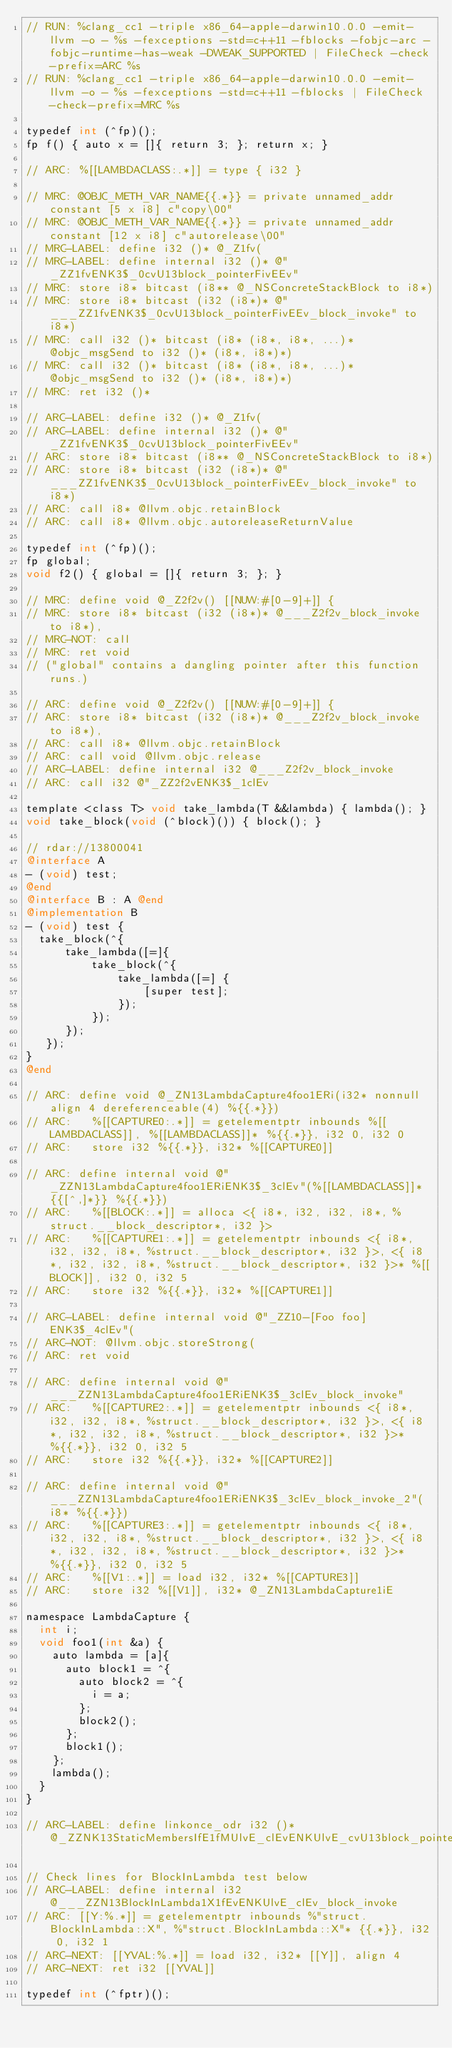<code> <loc_0><loc_0><loc_500><loc_500><_ObjectiveC_>// RUN: %clang_cc1 -triple x86_64-apple-darwin10.0.0 -emit-llvm -o - %s -fexceptions -std=c++11 -fblocks -fobjc-arc -fobjc-runtime-has-weak -DWEAK_SUPPORTED | FileCheck -check-prefix=ARC %s
// RUN: %clang_cc1 -triple x86_64-apple-darwin10.0.0 -emit-llvm -o - %s -fexceptions -std=c++11 -fblocks | FileCheck -check-prefix=MRC %s

typedef int (^fp)();
fp f() { auto x = []{ return 3; }; return x; }

// ARC: %[[LAMBDACLASS:.*]] = type { i32 }

// MRC: @OBJC_METH_VAR_NAME{{.*}} = private unnamed_addr constant [5 x i8] c"copy\00"
// MRC: @OBJC_METH_VAR_NAME{{.*}} = private unnamed_addr constant [12 x i8] c"autorelease\00"
// MRC-LABEL: define i32 ()* @_Z1fv(
// MRC-LABEL: define internal i32 ()* @"_ZZ1fvENK3$_0cvU13block_pointerFivEEv"
// MRC: store i8* bitcast (i8** @_NSConcreteStackBlock to i8*)
// MRC: store i8* bitcast (i32 (i8*)* @"___ZZ1fvENK3$_0cvU13block_pointerFivEEv_block_invoke" to i8*)
// MRC: call i32 ()* bitcast (i8* (i8*, i8*, ...)* @objc_msgSend to i32 ()* (i8*, i8*)*)
// MRC: call i32 ()* bitcast (i8* (i8*, i8*, ...)* @objc_msgSend to i32 ()* (i8*, i8*)*)
// MRC: ret i32 ()*

// ARC-LABEL: define i32 ()* @_Z1fv(
// ARC-LABEL: define internal i32 ()* @"_ZZ1fvENK3$_0cvU13block_pointerFivEEv"
// ARC: store i8* bitcast (i8** @_NSConcreteStackBlock to i8*)
// ARC: store i8* bitcast (i32 (i8*)* @"___ZZ1fvENK3$_0cvU13block_pointerFivEEv_block_invoke" to i8*)
// ARC: call i8* @llvm.objc.retainBlock
// ARC: call i8* @llvm.objc.autoreleaseReturnValue

typedef int (^fp)();
fp global;
void f2() { global = []{ return 3; }; }

// MRC: define void @_Z2f2v() [[NUW:#[0-9]+]] {
// MRC: store i8* bitcast (i32 (i8*)* @___Z2f2v_block_invoke to i8*),
// MRC-NOT: call
// MRC: ret void
// ("global" contains a dangling pointer after this function runs.)

// ARC: define void @_Z2f2v() [[NUW:#[0-9]+]] {
// ARC: store i8* bitcast (i32 (i8*)* @___Z2f2v_block_invoke to i8*),
// ARC: call i8* @llvm.objc.retainBlock
// ARC: call void @llvm.objc.release
// ARC-LABEL: define internal i32 @___Z2f2v_block_invoke
// ARC: call i32 @"_ZZ2f2vENK3$_1clEv

template <class T> void take_lambda(T &&lambda) { lambda(); }
void take_block(void (^block)()) { block(); }

// rdar://13800041
@interface A
- (void) test;
@end
@interface B : A @end
@implementation B
- (void) test {
  take_block(^{
      take_lambda([=]{
          take_block(^{
              take_lambda([=] {
                  [super test];
              });
          });
      });
   });
}
@end

// ARC: define void @_ZN13LambdaCapture4foo1ERi(i32* nonnull align 4 dereferenceable(4) %{{.*}})
// ARC:   %[[CAPTURE0:.*]] = getelementptr inbounds %[[LAMBDACLASS]], %[[LAMBDACLASS]]* %{{.*}}, i32 0, i32 0
// ARC:   store i32 %{{.*}}, i32* %[[CAPTURE0]]

// ARC: define internal void @"_ZZN13LambdaCapture4foo1ERiENK3$_3clEv"(%[[LAMBDACLASS]]* {{[^,]*}} %{{.*}})
// ARC:   %[[BLOCK:.*]] = alloca <{ i8*, i32, i32, i8*, %struct.__block_descriptor*, i32 }>
// ARC:   %[[CAPTURE1:.*]] = getelementptr inbounds <{ i8*, i32, i32, i8*, %struct.__block_descriptor*, i32 }>, <{ i8*, i32, i32, i8*, %struct.__block_descriptor*, i32 }>* %[[BLOCK]], i32 0, i32 5
// ARC:   store i32 %{{.*}}, i32* %[[CAPTURE1]]

// ARC-LABEL: define internal void @"_ZZ10-[Foo foo]ENK3$_4clEv"(
// ARC-NOT: @llvm.objc.storeStrong(
// ARC: ret void

// ARC: define internal void @"___ZZN13LambdaCapture4foo1ERiENK3$_3clEv_block_invoke"
// ARC:   %[[CAPTURE2:.*]] = getelementptr inbounds <{ i8*, i32, i32, i8*, %struct.__block_descriptor*, i32 }>, <{ i8*, i32, i32, i8*, %struct.__block_descriptor*, i32 }>* %{{.*}}, i32 0, i32 5
// ARC:   store i32 %{{.*}}, i32* %[[CAPTURE2]]

// ARC: define internal void @"___ZZN13LambdaCapture4foo1ERiENK3$_3clEv_block_invoke_2"(i8* %{{.*}})
// ARC:   %[[CAPTURE3:.*]] = getelementptr inbounds <{ i8*, i32, i32, i8*, %struct.__block_descriptor*, i32 }>, <{ i8*, i32, i32, i8*, %struct.__block_descriptor*, i32 }>* %{{.*}}, i32 0, i32 5
// ARC:   %[[V1:.*]] = load i32, i32* %[[CAPTURE3]]
// ARC:   store i32 %[[V1]], i32* @_ZN13LambdaCapture1iE

namespace LambdaCapture {
  int i;
  void foo1(int &a) {
    auto lambda = [a]{
      auto block1 = ^{
        auto block2 = ^{
          i = a;
        };
        block2();
      };
      block1();
    };
    lambda();
  }
}

// ARC-LABEL: define linkonce_odr i32 ()* @_ZZNK13StaticMembersIfE1fMUlvE_clEvENKUlvE_cvU13block_pointerFivEEv

// Check lines for BlockInLambda test below
// ARC-LABEL: define internal i32 @___ZZN13BlockInLambda1X1fEvENKUlvE_clEv_block_invoke
// ARC: [[Y:%.*]] = getelementptr inbounds %"struct.BlockInLambda::X", %"struct.BlockInLambda::X"* {{.*}}, i32 0, i32 1
// ARC-NEXT: [[YVAL:%.*]] = load i32, i32* [[Y]], align 4
// ARC-NEXT: ret i32 [[YVAL]]

typedef int (^fptr)();</code> 